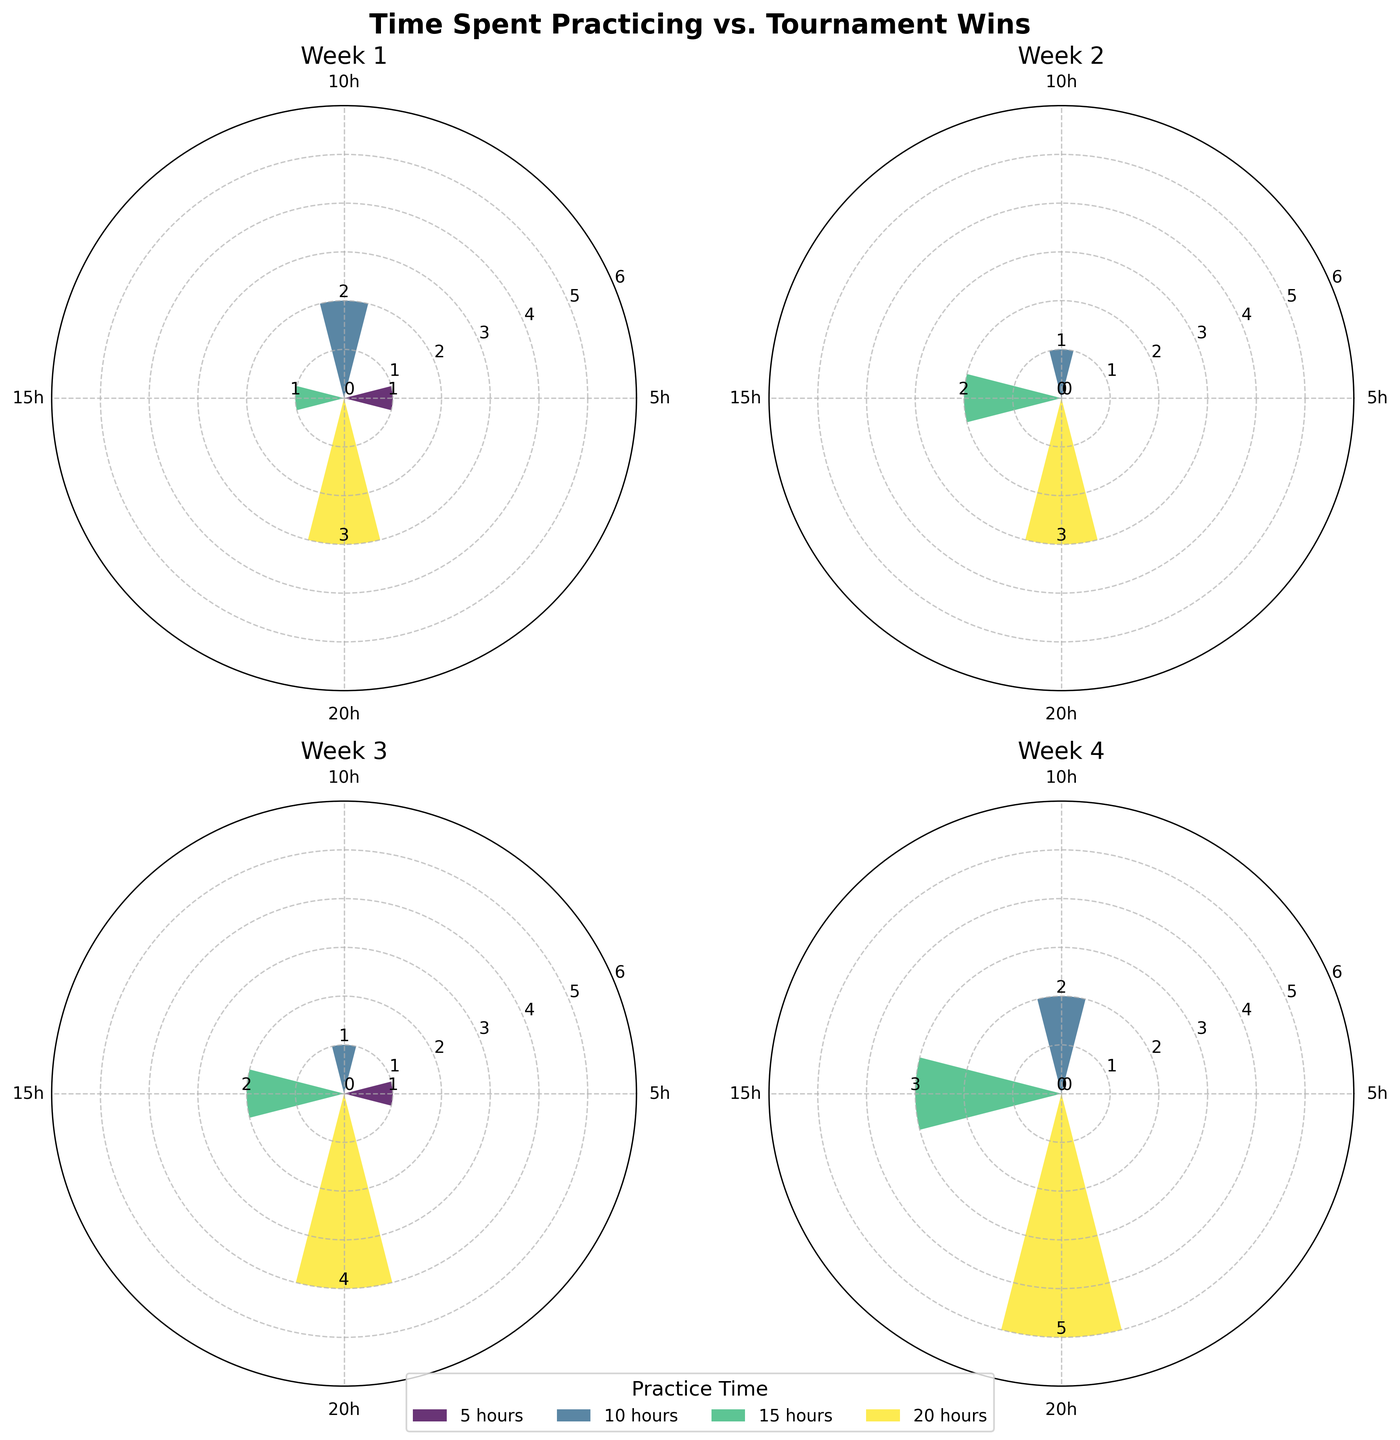What is the title of the figure? The title is directly provided at the top of the figure, summarizing its content. It states "Time Spent Practicing vs. Tournament Wins".
Answer: Time Spent Practicing vs. Tournament Wins How many intervals (weeks) are analyzed in the figure? By observing the subplots and their titles, there are a total of four intervals labeled as Week 1, Week 2, Week 3, and Week 4.
Answer: 4 Which week shows the highest number of tournament wins for 20 hours of practice? Checking the bars for 20 hours across all weeks, the height of the bar representing tournament wins shows the highest value in Week 4, with 5 wins.
Answer: Week 4 Compare the tournament wins for 10 hours of practice in Week 1 and Week 4. Which week has more wins? In Week 1, the 10-hour bar shows 2 wins, whereas in Week 4, it shows 2 wins as well. Both weeks have the same number of wins for 10 hours of practice.
Answer: Both weeks have 2 wins What is the minimum number of tournament wins for any given amount of practice time in Week 2? Looking at the bars in Week 2, the lowest bar height is for 5 hours of practice, indicating 0 wins.
Answer: 0 What is the average number of tournament wins for 15 hours of practice across all weeks? Summing up the wins for 15 hours in Week 1 (1 win), Week 2 (2 wins), Week 3 (2 wins), and Week 4 (3 wins) gives a total of 8 wins. Dividing by the 4 weeks, we get an average of 8/4.
Answer: 2 In which week does practicing 5 hours result in the maximum wins? By observing all weeks, Week 1 and Week 3 both have the highest 5-hour wins, each with 1 tournament win. Compared to other weeks (Week 2 and Week 4 with 0 wins), both Week 1 and 3 have the maximum.
Answer: Week 1 and Week 3 How many different practice time intervals are analyzed within each week? By counting the distinct bars within any given week subplot, there are four distinct practice time intervals (5, 10, 15, and 20 hours) represented in each week.
Answer: 4 Does any week have zero wins for all practice intervals? Checking the subplots of each week, there is no week where all bars representing practice intervals have a height of zero wins.
Answer: No 